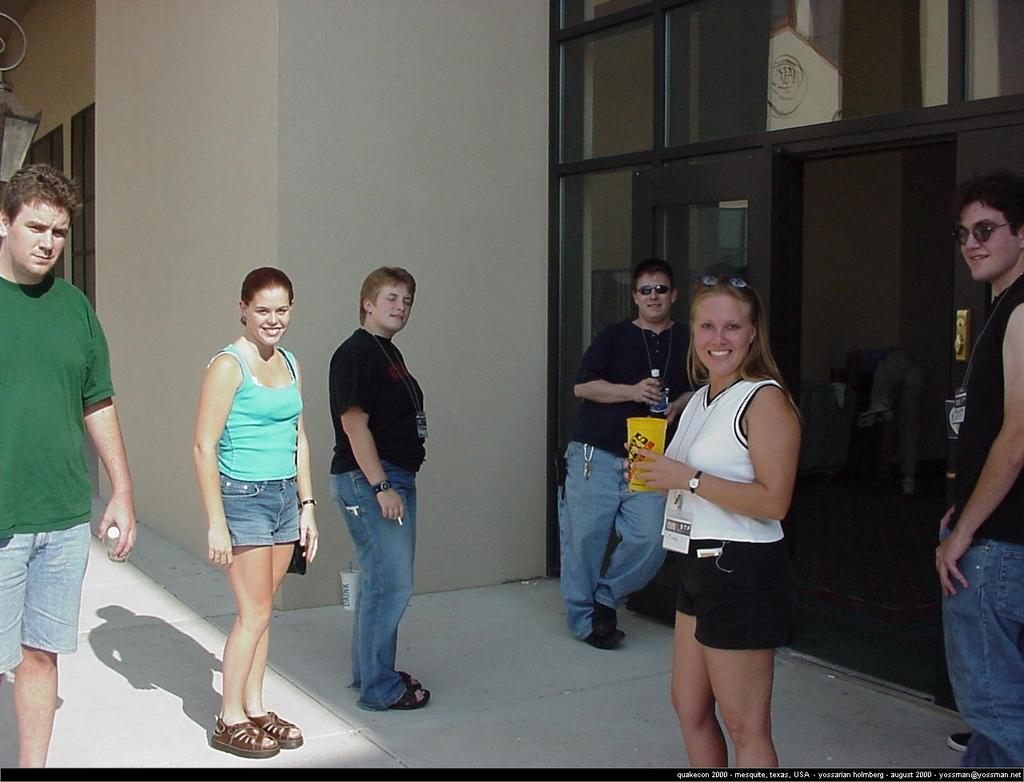What are the people in the image doing? The people in the center of the image are standing and smiling. What are the people holding in the image? The people are holding objects. What can be seen in the background of the image? There is a wall, glass, a lamp, and other objects in the background of the image. How many sisters are present in the image? There is no mention of sisters in the image, so we cannot determine the number of sisters present. 